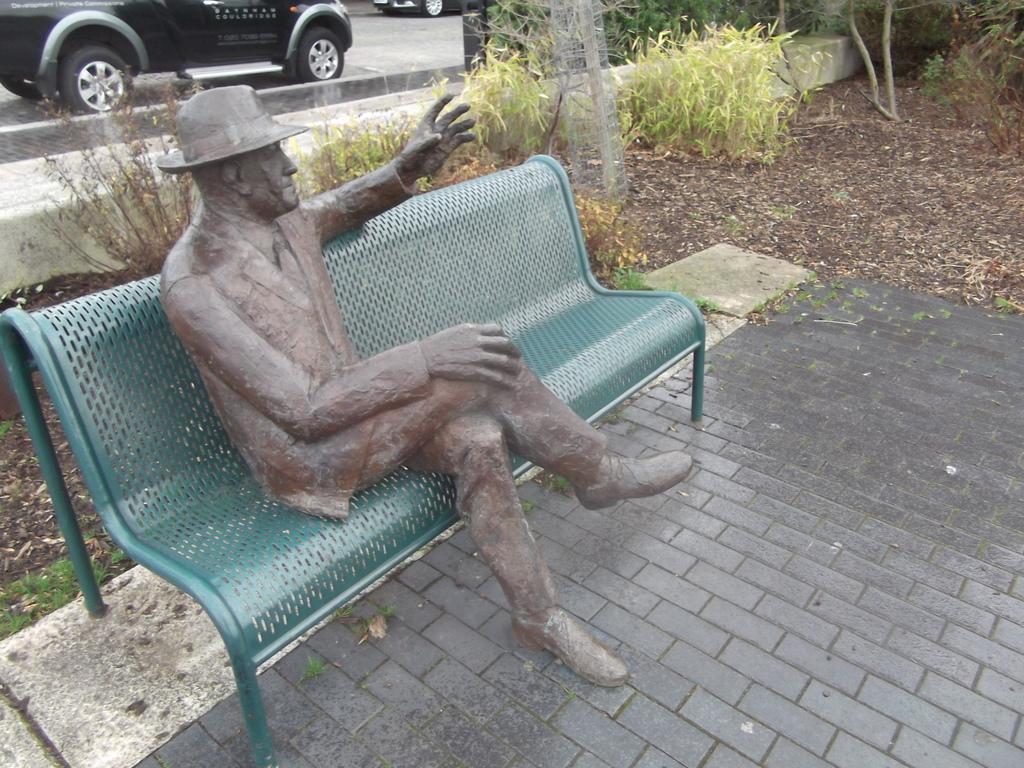Could you give a brief overview of what you see in this image? In this image we can see a statue on a bench. We can also see some plants, grass and some vehicles on the ground. 